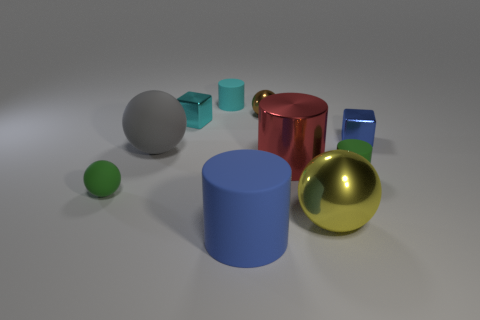Are there any patterns or symmetry in how the objects are arranged? The objects are arranged without strict symmetry or repeating patterns. They seem to be placed in a somewhat random, organic manner, suggesting a natural or impromptu assembly rather than a constructed or deliberate pattern. This arrangement might be intentional to create visual interest through variety and asymmetry. 